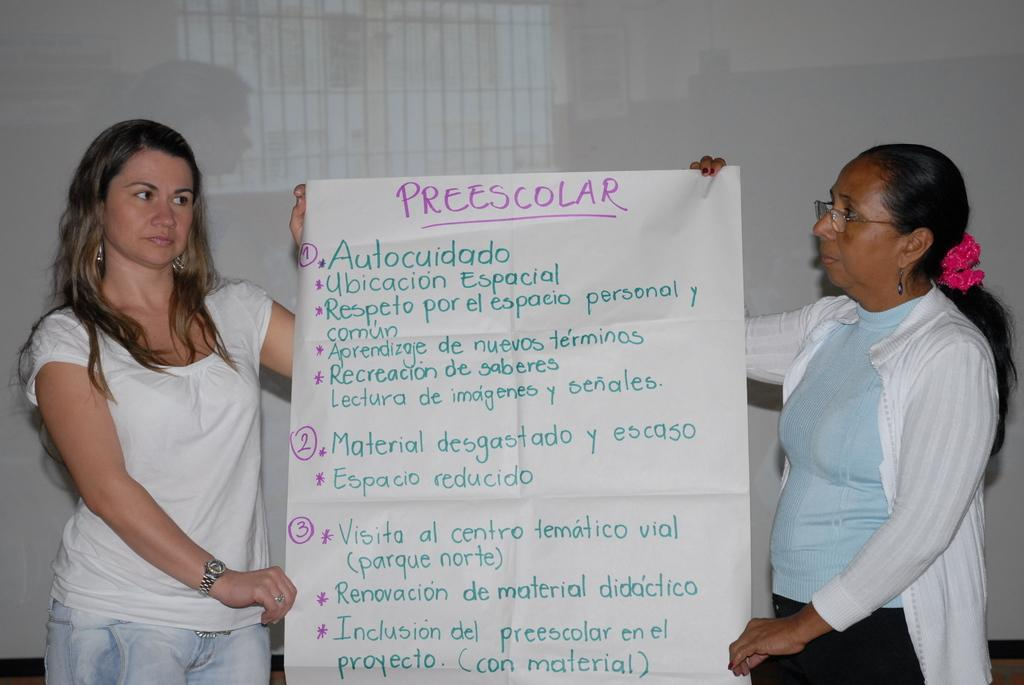How many people are in the image? There are two women in the image. What are the women doing in the image? The women are standing and holding a chart with their hands. What can be seen on the chart that the women are holding? There are letters written on the chart. On what surface is the image displayed? The image appears to be on a whiteboard. What time of day is it in the image, and are there any snails present? The time of day is not mentioned in the image, and there are no snails present. How are the women blowing on the chart in the image? The women are not blowing on the chart in the image; they are simply holding it with their hands. 